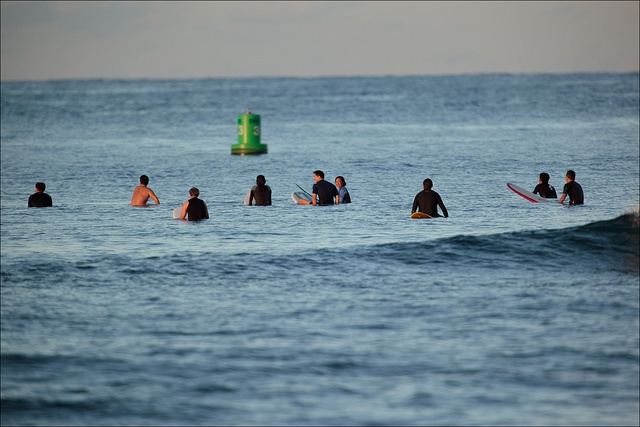Describe the objects in this image and their specific colors. I can see people in black, darkgray, maroon, and gray tones, people in black, gray, salmon, and brown tones, people in black, darkgray, maroon, and salmon tones, people in black, gray, maroon, and darkgray tones, and people in black, brown, and salmon tones in this image. 